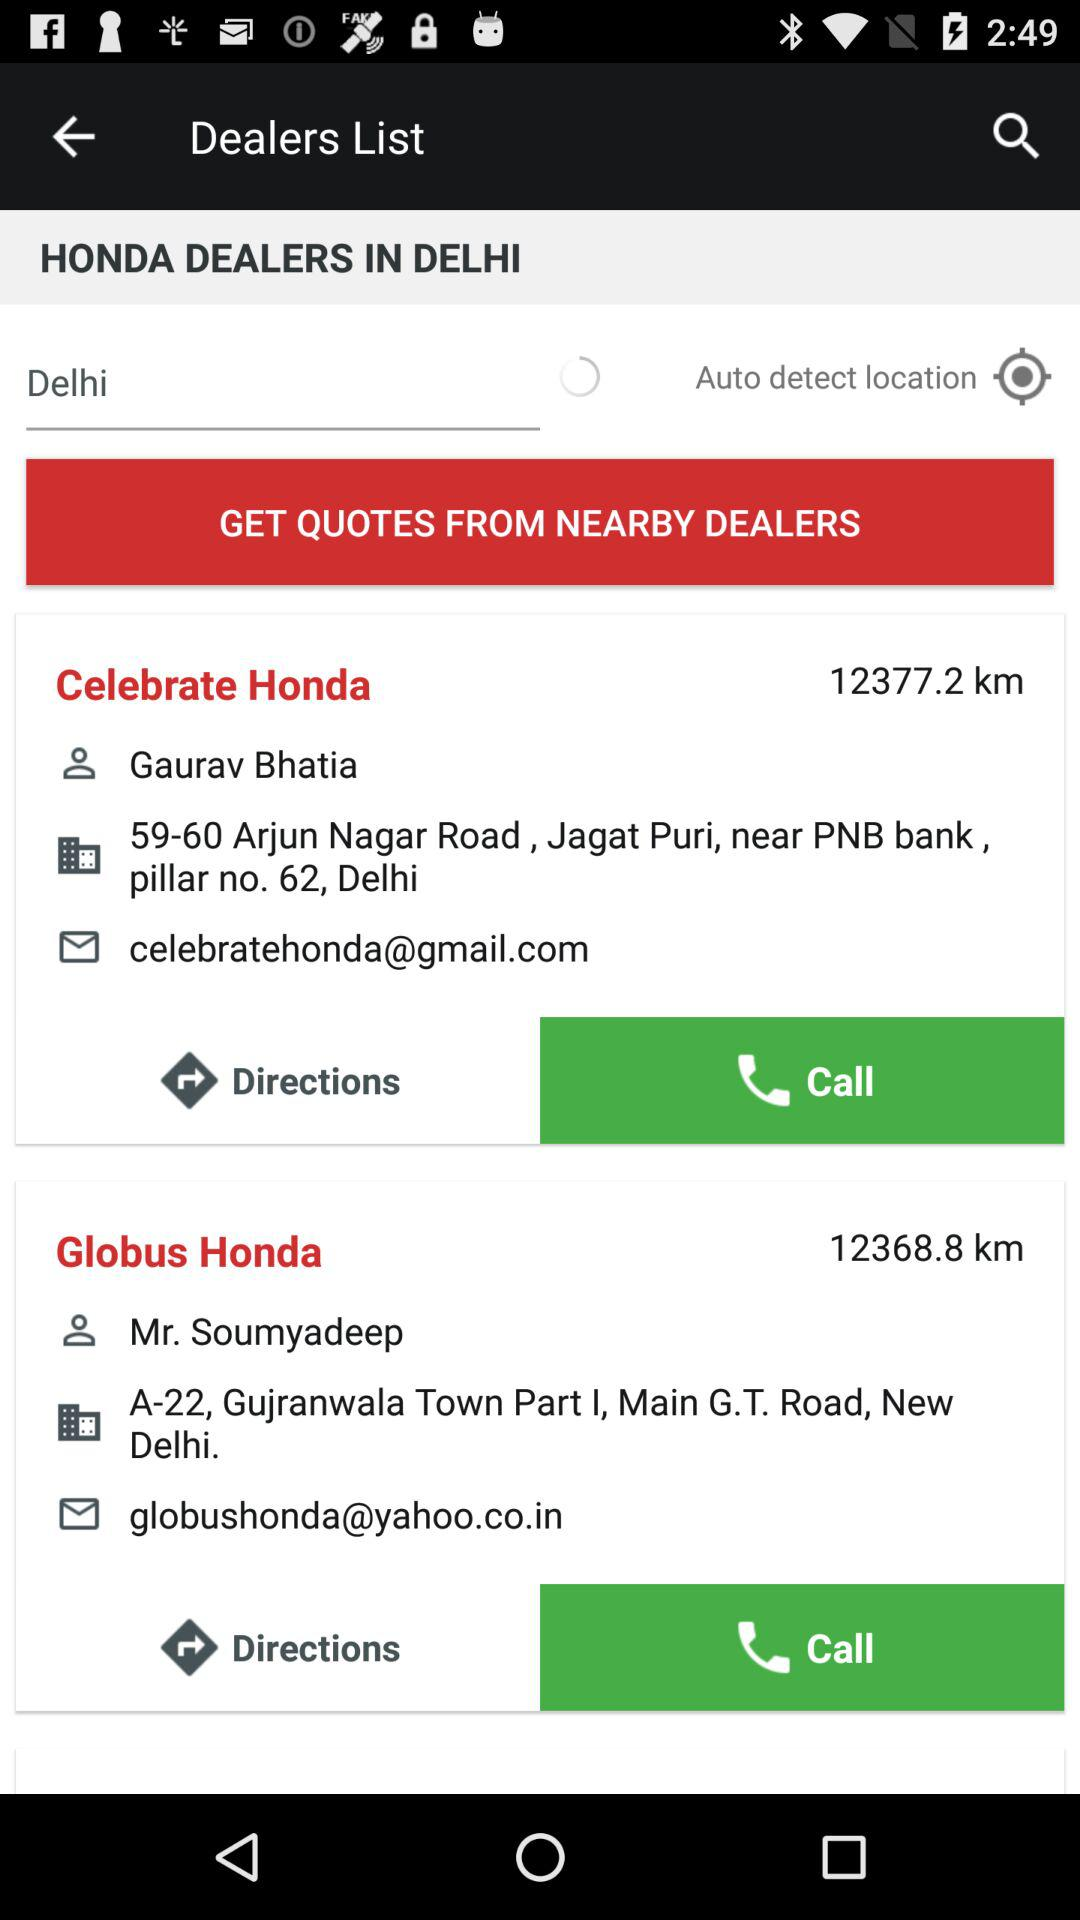How many dealers are there?
Answer the question using a single word or phrase. 2 